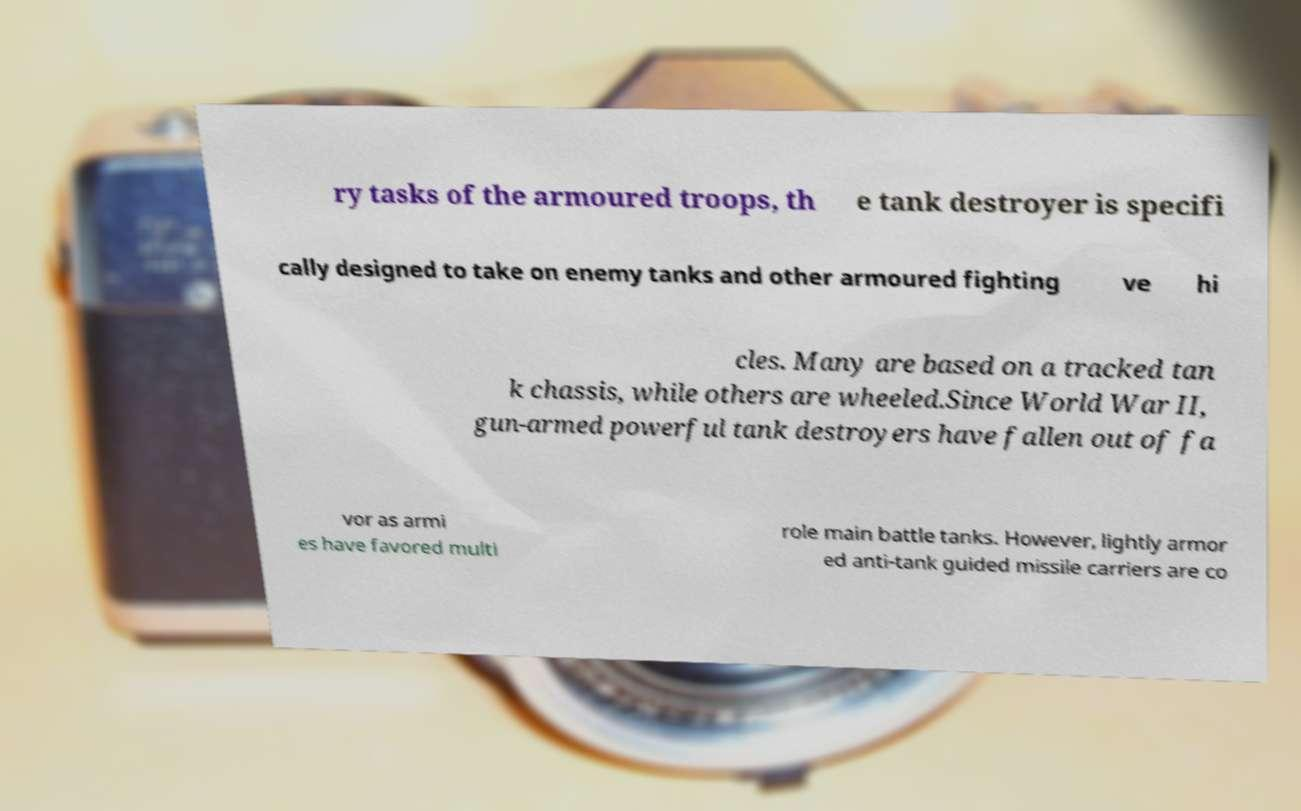Could you assist in decoding the text presented in this image and type it out clearly? ry tasks of the armoured troops, th e tank destroyer is specifi cally designed to take on enemy tanks and other armoured fighting ve hi cles. Many are based on a tracked tan k chassis, while others are wheeled.Since World War II, gun-armed powerful tank destroyers have fallen out of fa vor as armi es have favored multi role main battle tanks. However, lightly armor ed anti-tank guided missile carriers are co 